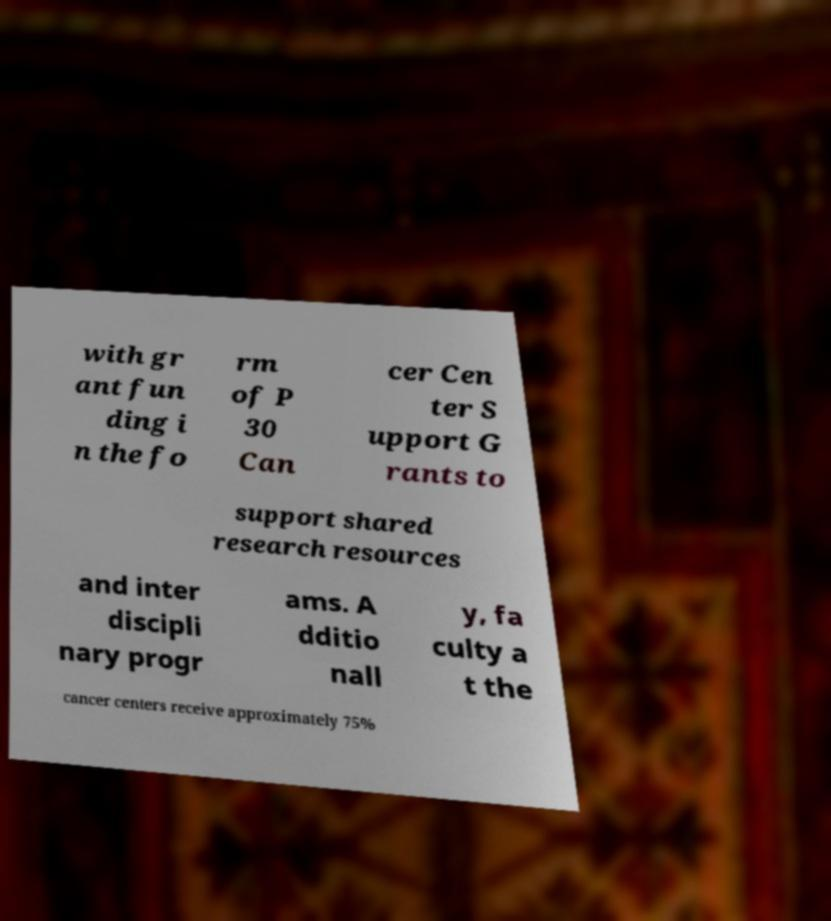I need the written content from this picture converted into text. Can you do that? with gr ant fun ding i n the fo rm of P 30 Can cer Cen ter S upport G rants to support shared research resources and inter discipli nary progr ams. A dditio nall y, fa culty a t the cancer centers receive approximately 75% 